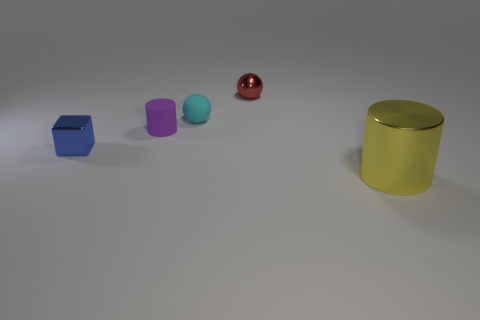Add 2 blue shiny balls. How many objects exist? 7 Subtract 1 cylinders. How many cylinders are left? 1 Subtract all blocks. How many objects are left? 4 Add 3 red balls. How many red balls are left? 4 Add 4 tiny red metallic things. How many tiny red metallic things exist? 5 Subtract 0 brown blocks. How many objects are left? 5 Subtract all green cylinders. Subtract all red balls. How many cylinders are left? 2 Subtract all large cyan shiny balls. Subtract all yellow metal cylinders. How many objects are left? 4 